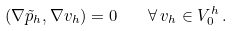<formula> <loc_0><loc_0><loc_500><loc_500>( \nabla \tilde { p } _ { h } , \nabla v _ { h } ) = 0 \quad \forall \, v _ { h } \in V _ { 0 } ^ { h } \, .</formula> 